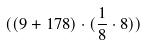<formula> <loc_0><loc_0><loc_500><loc_500>( ( 9 + 1 7 8 ) \cdot ( \frac { 1 } { 8 } \cdot 8 ) )</formula> 